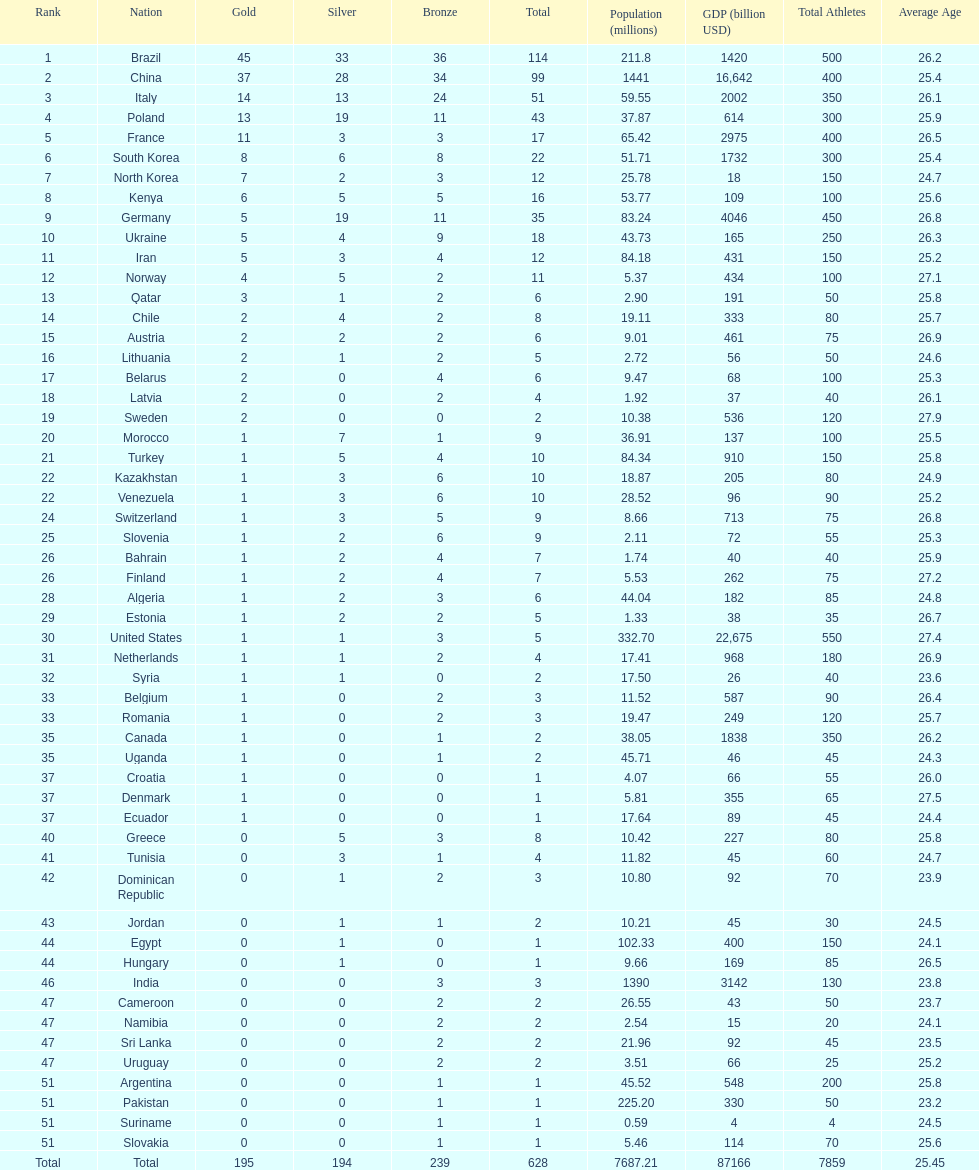Who only won 13 silver medals? Italy. 